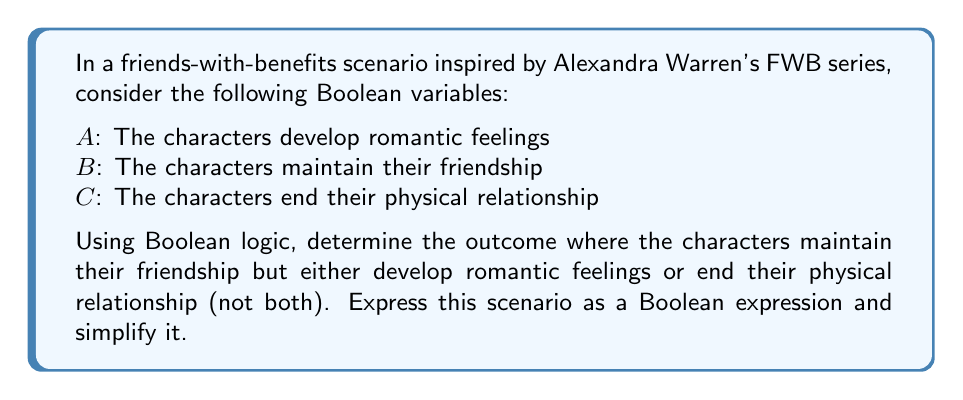Could you help me with this problem? Let's approach this step-by-step:

1) We want a scenario where $B$ is true (maintain friendship), and either $A$ is true (develop feelings) or $C$ is true (end physical relationship), but not both.

2) This can be expressed as: $B \wedge (A \oplus C)$, where $\oplus$ represents the XOR (exclusive OR) operation.

3) We can expand the XOR operation using its definition:
   $B \wedge ((A \wedge \neg C) \vee (\neg A \wedge C))$

4) Using the distributive property of AND over OR:
   $(B \wedge A \wedge \neg C) \vee (B \wedge \neg A \wedge C)$

5) This expression cannot be simplified further using Boolean algebra laws.

The final expression $(B \wedge A \wedge \neg C) \vee (B \wedge \neg A \wedge C)$ represents two possible outcomes:
- The characters maintain their friendship, develop romantic feelings, and don't end their physical relationship.
- The characters maintain their friendship, don't develop romantic feelings, and end their physical relationship.
Answer: $(B \wedge A \wedge \neg C) \vee (B \wedge \neg A \wedge C)$ 